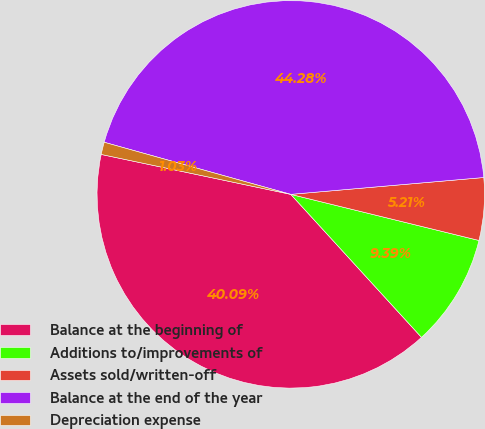Convert chart to OTSL. <chart><loc_0><loc_0><loc_500><loc_500><pie_chart><fcel>Balance at the beginning of<fcel>Additions to/improvements of<fcel>Assets sold/written-off<fcel>Balance at the end of the year<fcel>Depreciation expense<nl><fcel>40.09%<fcel>9.39%<fcel>5.21%<fcel>44.28%<fcel>1.03%<nl></chart> 